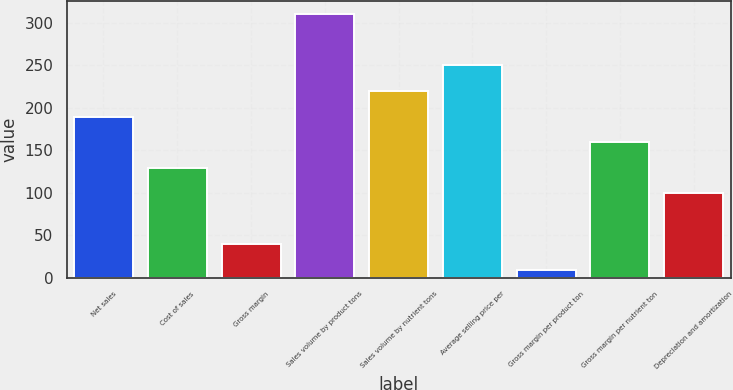Convert chart to OTSL. <chart><loc_0><loc_0><loc_500><loc_500><bar_chart><fcel>Net sales<fcel>Cost of sales<fcel>Gross margin<fcel>Sales volume by product tons<fcel>Sales volume by nutrient tons<fcel>Average selling price per<fcel>Gross margin per product ton<fcel>Gross margin per nutrient ton<fcel>Depreciation and amortization<nl><fcel>189.6<fcel>129.4<fcel>39.1<fcel>310<fcel>219.7<fcel>249.8<fcel>9<fcel>159.5<fcel>99.3<nl></chart> 